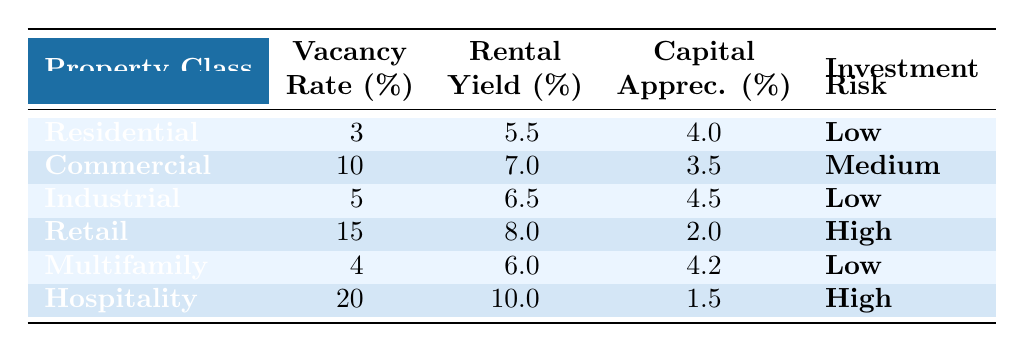What is the vacancy rate for Residential properties? The table indicates that the vacancy rate for Residential properties is listed under the "Vacancy Rate (%)" column next to "Residential". The value is 3%.
Answer: 3% Which property class has the highest rental yield? By comparing the "Rental Yield (%)" values in the table, we observe that Hospitality has the highest rental yield at 10%.
Answer: Hospitality What is the average capital appreciation across all property classes? To find the average capital appreciation, we sum the capital appreciation values: (4.0 + 3.5 + 4.5 + 2.0 + 4.2 + 1.5) = 19.7. There are 6 property classes, so the average is 19.7 / 6 = 3.28.
Answer: 3.28 Is the investment risk for Multifamily properties low? The table states that the investment risk for Multifamily is recorded as "Low" in the "Investment Risk" column, which confirms it is indeed low.
Answer: Yes Which property classes have a vacancy rate greater than 10%? By examining the "Vacancy Rate (%)" column, we note that only Commercial (10%) and Hospitality (20%) have rates equal to or greater than 10%. Thus, the classes meeting this criterion are Commercial and Hospitality.
Answer: Commercial, Hospitality What is the difference in rental yield between Retail and Industrial properties? The rental yield for Retail is 8.0% and for Industrial is 6.5%. The difference is calculated as 8.0% - 6.5% = 1.5%.
Answer: 1.5% Are there any property classes with both high rental yield and high investment risk? Checking the table, Retail (8.0%, High) and Hospitality (10.0%, High) are found to have high rental yields along with high investment risks. Thus, there are two property classes that meet this condition.
Answer: Yes What is the lowest capital appreciation among all property classes? The table lists capital appreciation values, and the lowest value is 1.5%, which corresponds to the Hospitality property class.
Answer: 1.5% Which property class has the second-lowest vacancy rate? The vacancy rates from lowest to highest are: Residential (3%), Multifamily (4%), Industrial (5%), Commercial (10%), Retail (15%), Hospitality (20%). Multifamily, with a vacancy rate of 4%, is the second-lowest.
Answer: Multifamily 